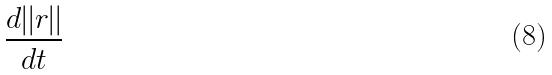Convert formula to latex. <formula><loc_0><loc_0><loc_500><loc_500>\frac { d | | r | | } { d t }</formula> 